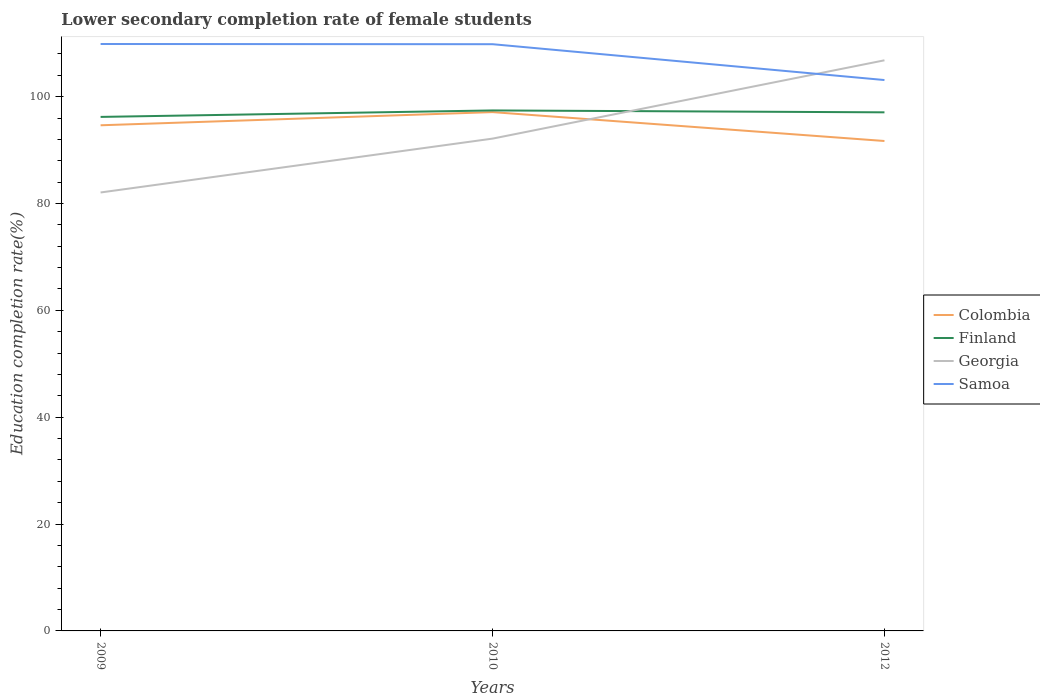Across all years, what is the maximum lower secondary completion rate of female students in Finland?
Your response must be concise. 96.21. What is the total lower secondary completion rate of female students in Finland in the graph?
Ensure brevity in your answer.  0.36. What is the difference between the highest and the second highest lower secondary completion rate of female students in Finland?
Provide a short and direct response. 1.21. Is the lower secondary completion rate of female students in Finland strictly greater than the lower secondary completion rate of female students in Georgia over the years?
Make the answer very short. No. Does the graph contain grids?
Your answer should be compact. No. Where does the legend appear in the graph?
Provide a succinct answer. Center right. How many legend labels are there?
Ensure brevity in your answer.  4. How are the legend labels stacked?
Provide a short and direct response. Vertical. What is the title of the graph?
Make the answer very short. Lower secondary completion rate of female students. Does "Rwanda" appear as one of the legend labels in the graph?
Offer a terse response. No. What is the label or title of the Y-axis?
Provide a succinct answer. Education completion rate(%). What is the Education completion rate(%) of Colombia in 2009?
Your answer should be compact. 94.64. What is the Education completion rate(%) of Finland in 2009?
Make the answer very short. 96.21. What is the Education completion rate(%) of Georgia in 2009?
Offer a terse response. 82.06. What is the Education completion rate(%) in Samoa in 2009?
Provide a succinct answer. 109.85. What is the Education completion rate(%) of Colombia in 2010?
Keep it short and to the point. 97.11. What is the Education completion rate(%) of Finland in 2010?
Ensure brevity in your answer.  97.42. What is the Education completion rate(%) in Georgia in 2010?
Your answer should be very brief. 92.14. What is the Education completion rate(%) in Samoa in 2010?
Provide a succinct answer. 109.82. What is the Education completion rate(%) in Colombia in 2012?
Your answer should be very brief. 91.7. What is the Education completion rate(%) of Finland in 2012?
Make the answer very short. 97.06. What is the Education completion rate(%) of Georgia in 2012?
Give a very brief answer. 106.8. What is the Education completion rate(%) of Samoa in 2012?
Make the answer very short. 103.11. Across all years, what is the maximum Education completion rate(%) in Colombia?
Ensure brevity in your answer.  97.11. Across all years, what is the maximum Education completion rate(%) of Finland?
Your response must be concise. 97.42. Across all years, what is the maximum Education completion rate(%) of Georgia?
Your answer should be compact. 106.8. Across all years, what is the maximum Education completion rate(%) in Samoa?
Make the answer very short. 109.85. Across all years, what is the minimum Education completion rate(%) in Colombia?
Provide a succinct answer. 91.7. Across all years, what is the minimum Education completion rate(%) of Finland?
Make the answer very short. 96.21. Across all years, what is the minimum Education completion rate(%) of Georgia?
Make the answer very short. 82.06. Across all years, what is the minimum Education completion rate(%) of Samoa?
Offer a terse response. 103.11. What is the total Education completion rate(%) of Colombia in the graph?
Your answer should be compact. 283.44. What is the total Education completion rate(%) in Finland in the graph?
Ensure brevity in your answer.  290.69. What is the total Education completion rate(%) in Georgia in the graph?
Make the answer very short. 281.01. What is the total Education completion rate(%) in Samoa in the graph?
Your answer should be very brief. 322.77. What is the difference between the Education completion rate(%) of Colombia in 2009 and that in 2010?
Offer a very short reply. -2.47. What is the difference between the Education completion rate(%) of Finland in 2009 and that in 2010?
Your response must be concise. -1.21. What is the difference between the Education completion rate(%) in Georgia in 2009 and that in 2010?
Offer a very short reply. -10.08. What is the difference between the Education completion rate(%) of Samoa in 2009 and that in 2010?
Keep it short and to the point. 0.04. What is the difference between the Education completion rate(%) of Colombia in 2009 and that in 2012?
Give a very brief answer. 2.94. What is the difference between the Education completion rate(%) in Finland in 2009 and that in 2012?
Provide a succinct answer. -0.86. What is the difference between the Education completion rate(%) of Georgia in 2009 and that in 2012?
Your answer should be compact. -24.74. What is the difference between the Education completion rate(%) in Samoa in 2009 and that in 2012?
Provide a succinct answer. 6.75. What is the difference between the Education completion rate(%) of Colombia in 2010 and that in 2012?
Ensure brevity in your answer.  5.41. What is the difference between the Education completion rate(%) in Finland in 2010 and that in 2012?
Ensure brevity in your answer.  0.36. What is the difference between the Education completion rate(%) in Georgia in 2010 and that in 2012?
Your answer should be compact. -14.66. What is the difference between the Education completion rate(%) in Samoa in 2010 and that in 2012?
Provide a short and direct response. 6.71. What is the difference between the Education completion rate(%) in Colombia in 2009 and the Education completion rate(%) in Finland in 2010?
Ensure brevity in your answer.  -2.78. What is the difference between the Education completion rate(%) of Colombia in 2009 and the Education completion rate(%) of Georgia in 2010?
Offer a terse response. 2.5. What is the difference between the Education completion rate(%) in Colombia in 2009 and the Education completion rate(%) in Samoa in 2010?
Make the answer very short. -15.18. What is the difference between the Education completion rate(%) of Finland in 2009 and the Education completion rate(%) of Georgia in 2010?
Provide a short and direct response. 4.06. What is the difference between the Education completion rate(%) of Finland in 2009 and the Education completion rate(%) of Samoa in 2010?
Your response must be concise. -13.61. What is the difference between the Education completion rate(%) in Georgia in 2009 and the Education completion rate(%) in Samoa in 2010?
Keep it short and to the point. -27.75. What is the difference between the Education completion rate(%) of Colombia in 2009 and the Education completion rate(%) of Finland in 2012?
Keep it short and to the point. -2.42. What is the difference between the Education completion rate(%) of Colombia in 2009 and the Education completion rate(%) of Georgia in 2012?
Ensure brevity in your answer.  -12.16. What is the difference between the Education completion rate(%) in Colombia in 2009 and the Education completion rate(%) in Samoa in 2012?
Ensure brevity in your answer.  -8.47. What is the difference between the Education completion rate(%) in Finland in 2009 and the Education completion rate(%) in Georgia in 2012?
Provide a succinct answer. -10.59. What is the difference between the Education completion rate(%) in Finland in 2009 and the Education completion rate(%) in Samoa in 2012?
Your answer should be compact. -6.9. What is the difference between the Education completion rate(%) in Georgia in 2009 and the Education completion rate(%) in Samoa in 2012?
Your answer should be compact. -21.04. What is the difference between the Education completion rate(%) of Colombia in 2010 and the Education completion rate(%) of Finland in 2012?
Provide a short and direct response. 0.04. What is the difference between the Education completion rate(%) in Colombia in 2010 and the Education completion rate(%) in Georgia in 2012?
Provide a succinct answer. -9.7. What is the difference between the Education completion rate(%) of Colombia in 2010 and the Education completion rate(%) of Samoa in 2012?
Your response must be concise. -6. What is the difference between the Education completion rate(%) in Finland in 2010 and the Education completion rate(%) in Georgia in 2012?
Provide a succinct answer. -9.38. What is the difference between the Education completion rate(%) of Finland in 2010 and the Education completion rate(%) of Samoa in 2012?
Offer a very short reply. -5.69. What is the difference between the Education completion rate(%) in Georgia in 2010 and the Education completion rate(%) in Samoa in 2012?
Make the answer very short. -10.97. What is the average Education completion rate(%) in Colombia per year?
Give a very brief answer. 94.48. What is the average Education completion rate(%) in Finland per year?
Your answer should be compact. 96.9. What is the average Education completion rate(%) in Georgia per year?
Give a very brief answer. 93.67. What is the average Education completion rate(%) of Samoa per year?
Your answer should be compact. 107.59. In the year 2009, what is the difference between the Education completion rate(%) of Colombia and Education completion rate(%) of Finland?
Your answer should be very brief. -1.57. In the year 2009, what is the difference between the Education completion rate(%) of Colombia and Education completion rate(%) of Georgia?
Your answer should be compact. 12.58. In the year 2009, what is the difference between the Education completion rate(%) of Colombia and Education completion rate(%) of Samoa?
Offer a very short reply. -15.21. In the year 2009, what is the difference between the Education completion rate(%) of Finland and Education completion rate(%) of Georgia?
Give a very brief answer. 14.14. In the year 2009, what is the difference between the Education completion rate(%) in Finland and Education completion rate(%) in Samoa?
Your response must be concise. -13.65. In the year 2009, what is the difference between the Education completion rate(%) of Georgia and Education completion rate(%) of Samoa?
Offer a terse response. -27.79. In the year 2010, what is the difference between the Education completion rate(%) of Colombia and Education completion rate(%) of Finland?
Keep it short and to the point. -0.31. In the year 2010, what is the difference between the Education completion rate(%) in Colombia and Education completion rate(%) in Georgia?
Keep it short and to the point. 4.96. In the year 2010, what is the difference between the Education completion rate(%) in Colombia and Education completion rate(%) in Samoa?
Your answer should be very brief. -12.71. In the year 2010, what is the difference between the Education completion rate(%) of Finland and Education completion rate(%) of Georgia?
Make the answer very short. 5.28. In the year 2010, what is the difference between the Education completion rate(%) in Finland and Education completion rate(%) in Samoa?
Provide a succinct answer. -12.4. In the year 2010, what is the difference between the Education completion rate(%) in Georgia and Education completion rate(%) in Samoa?
Provide a succinct answer. -17.67. In the year 2012, what is the difference between the Education completion rate(%) of Colombia and Education completion rate(%) of Finland?
Provide a succinct answer. -5.37. In the year 2012, what is the difference between the Education completion rate(%) in Colombia and Education completion rate(%) in Georgia?
Ensure brevity in your answer.  -15.1. In the year 2012, what is the difference between the Education completion rate(%) of Colombia and Education completion rate(%) of Samoa?
Offer a terse response. -11.41. In the year 2012, what is the difference between the Education completion rate(%) of Finland and Education completion rate(%) of Georgia?
Your answer should be very brief. -9.74. In the year 2012, what is the difference between the Education completion rate(%) of Finland and Education completion rate(%) of Samoa?
Ensure brevity in your answer.  -6.04. In the year 2012, what is the difference between the Education completion rate(%) of Georgia and Education completion rate(%) of Samoa?
Your answer should be compact. 3.69. What is the ratio of the Education completion rate(%) in Colombia in 2009 to that in 2010?
Your answer should be very brief. 0.97. What is the ratio of the Education completion rate(%) of Finland in 2009 to that in 2010?
Keep it short and to the point. 0.99. What is the ratio of the Education completion rate(%) in Georgia in 2009 to that in 2010?
Your response must be concise. 0.89. What is the ratio of the Education completion rate(%) of Samoa in 2009 to that in 2010?
Your response must be concise. 1. What is the ratio of the Education completion rate(%) of Colombia in 2009 to that in 2012?
Ensure brevity in your answer.  1.03. What is the ratio of the Education completion rate(%) of Georgia in 2009 to that in 2012?
Ensure brevity in your answer.  0.77. What is the ratio of the Education completion rate(%) of Samoa in 2009 to that in 2012?
Your response must be concise. 1.07. What is the ratio of the Education completion rate(%) in Colombia in 2010 to that in 2012?
Your response must be concise. 1.06. What is the ratio of the Education completion rate(%) of Finland in 2010 to that in 2012?
Keep it short and to the point. 1. What is the ratio of the Education completion rate(%) in Georgia in 2010 to that in 2012?
Give a very brief answer. 0.86. What is the ratio of the Education completion rate(%) in Samoa in 2010 to that in 2012?
Your answer should be compact. 1.07. What is the difference between the highest and the second highest Education completion rate(%) in Colombia?
Keep it short and to the point. 2.47. What is the difference between the highest and the second highest Education completion rate(%) of Finland?
Offer a very short reply. 0.36. What is the difference between the highest and the second highest Education completion rate(%) of Georgia?
Your answer should be very brief. 14.66. What is the difference between the highest and the second highest Education completion rate(%) of Samoa?
Make the answer very short. 0.04. What is the difference between the highest and the lowest Education completion rate(%) in Colombia?
Your answer should be very brief. 5.41. What is the difference between the highest and the lowest Education completion rate(%) in Finland?
Ensure brevity in your answer.  1.21. What is the difference between the highest and the lowest Education completion rate(%) in Georgia?
Your response must be concise. 24.74. What is the difference between the highest and the lowest Education completion rate(%) in Samoa?
Your answer should be very brief. 6.75. 